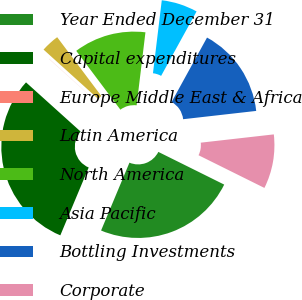<chart> <loc_0><loc_0><loc_500><loc_500><pie_chart><fcel>Year Ended December 31<fcel>Capital expenditures<fcel>Europe Middle East & Africa<fcel>Latin America<fcel>North America<fcel>Asia Pacific<fcel>Bottling Investments<fcel>Corporate<nl><fcel>23.97%<fcel>30.37%<fcel>0.02%<fcel>3.06%<fcel>12.16%<fcel>6.09%<fcel>15.2%<fcel>9.13%<nl></chart> 